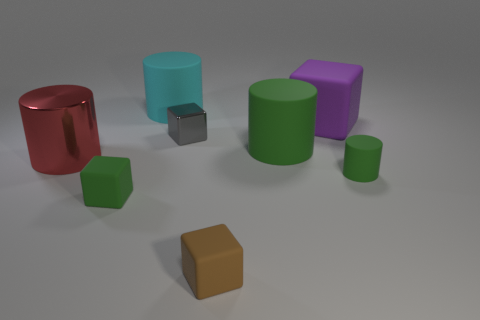Subtract 1 blocks. How many blocks are left? 3 Add 2 large cyan matte things. How many objects exist? 10 Add 7 red metallic cylinders. How many red metallic cylinders are left? 8 Add 4 purple rubber spheres. How many purple rubber spheres exist? 4 Subtract 0 gray balls. How many objects are left? 8 Subtract all large cyan cylinders. Subtract all big matte cylinders. How many objects are left? 5 